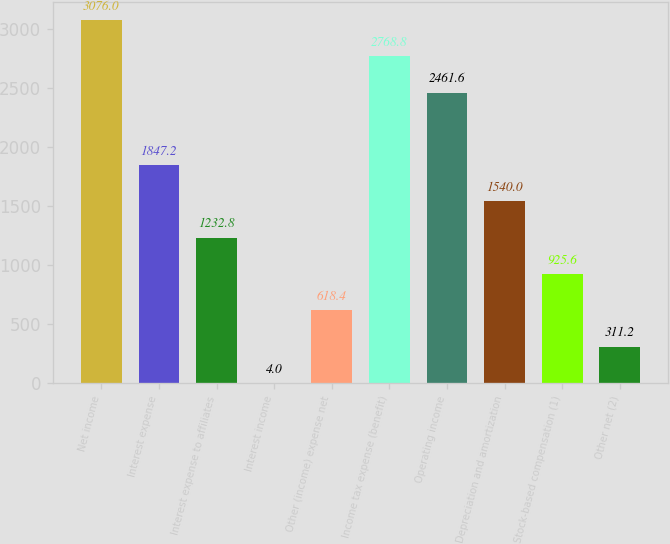Convert chart to OTSL. <chart><loc_0><loc_0><loc_500><loc_500><bar_chart><fcel>Net income<fcel>Interest expense<fcel>Interest expense to affiliates<fcel>Interest income<fcel>Other (income) expense net<fcel>Income tax expense (benefit)<fcel>Operating income<fcel>Depreciation and amortization<fcel>Stock-based compensation (1)<fcel>Other net (2)<nl><fcel>3076<fcel>1847.2<fcel>1232.8<fcel>4<fcel>618.4<fcel>2768.8<fcel>2461.6<fcel>1540<fcel>925.6<fcel>311.2<nl></chart> 